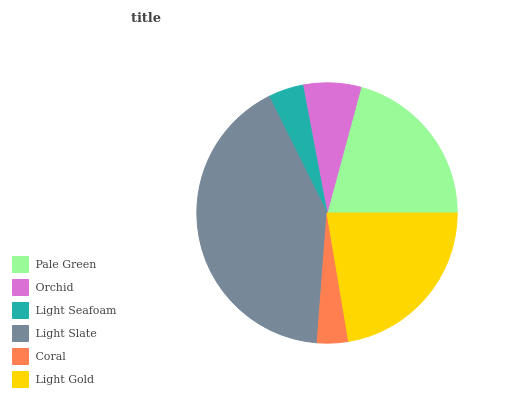Is Coral the minimum?
Answer yes or no. Yes. Is Light Slate the maximum?
Answer yes or no. Yes. Is Orchid the minimum?
Answer yes or no. No. Is Orchid the maximum?
Answer yes or no. No. Is Pale Green greater than Orchid?
Answer yes or no. Yes. Is Orchid less than Pale Green?
Answer yes or no. Yes. Is Orchid greater than Pale Green?
Answer yes or no. No. Is Pale Green less than Orchid?
Answer yes or no. No. Is Pale Green the high median?
Answer yes or no. Yes. Is Orchid the low median?
Answer yes or no. Yes. Is Orchid the high median?
Answer yes or no. No. Is Pale Green the low median?
Answer yes or no. No. 